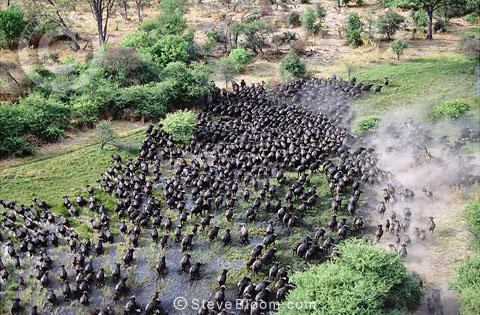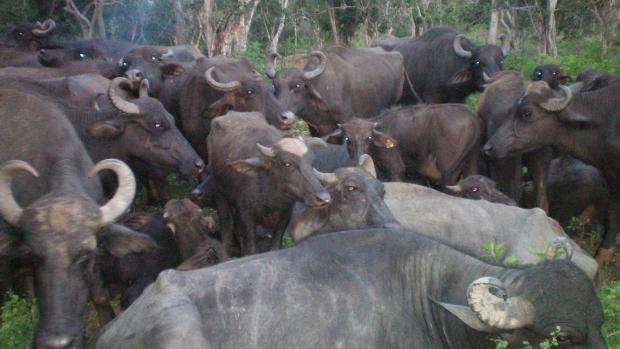The first image is the image on the left, the second image is the image on the right. Assess this claim about the two images: "The left image shows a fog-like cloud above a herd of dark hooved animals moving en masse.". Correct or not? Answer yes or no. Yes. 